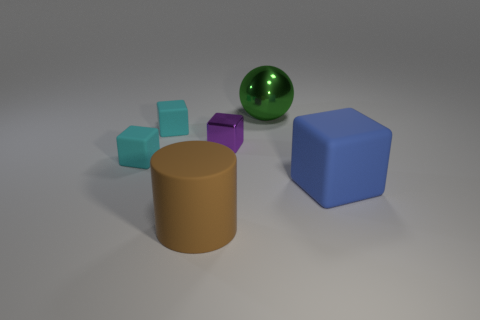Which objects have the same shape but different sizes? The cubes present an interesting study in similarity and contrast. All of them have the same angular, six-faced shape, yet their sizes create a delightful composition of scale, ranging from small to large. Can you describe the texture and material of the objects? Certainly! Each object appears to have a smooth, almost matte finish, suggesting a non-reflective, possibly plastic material. The uniformity in texture across the different shapes delivers a cohesive quality to the collection. 